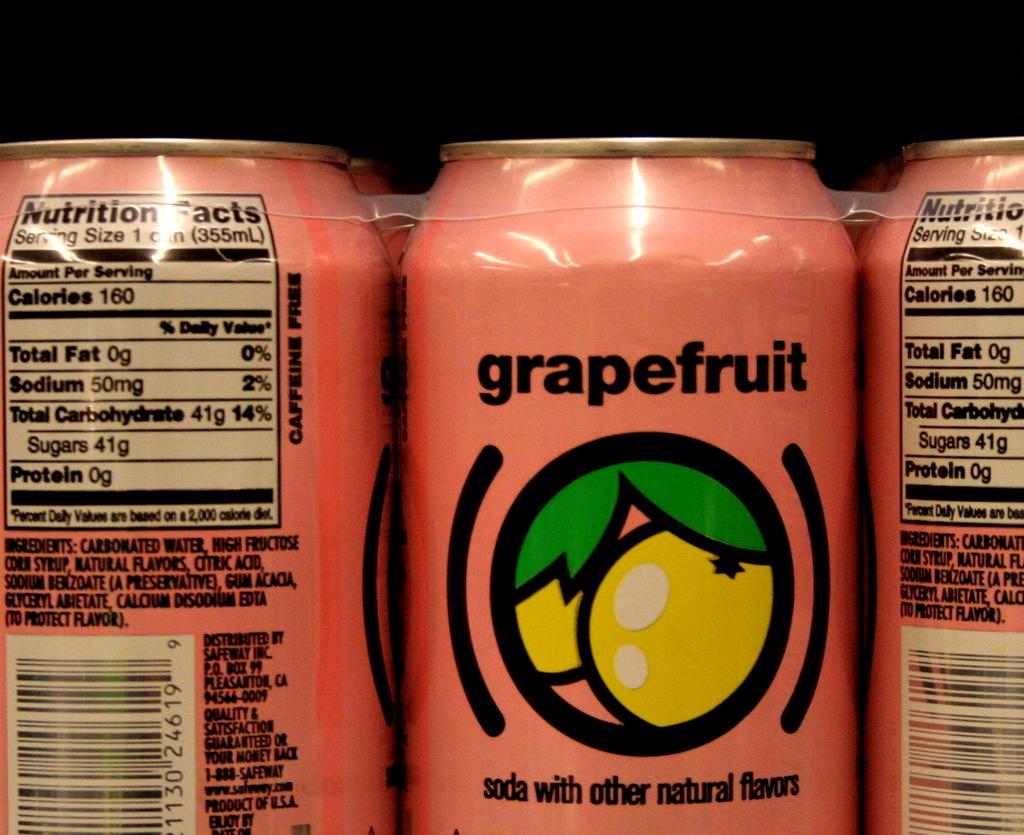What is the flavor of this soda?
Keep it short and to the point. Grapefruit. How many calories per drink?
Offer a terse response. 160. 